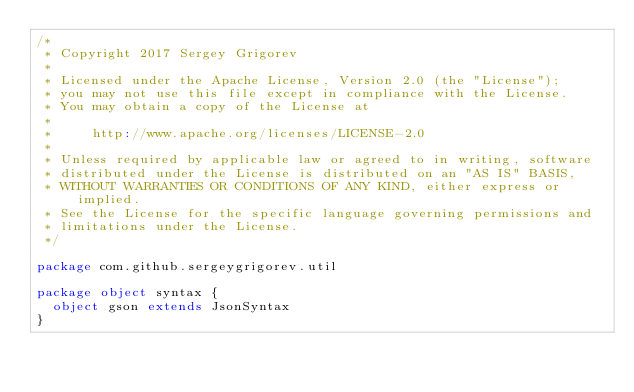<code> <loc_0><loc_0><loc_500><loc_500><_Scala_>/*
 * Copyright 2017 Sergey Grigorev
 *
 * Licensed under the Apache License, Version 2.0 (the "License");
 * you may not use this file except in compliance with the License.
 * You may obtain a copy of the License at
 *
 *     http://www.apache.org/licenses/LICENSE-2.0
 *
 * Unless required by applicable law or agreed to in writing, software
 * distributed under the License is distributed on an "AS IS" BASIS,
 * WITHOUT WARRANTIES OR CONDITIONS OF ANY KIND, either express or implied.
 * See the License for the specific language governing permissions and
 * limitations under the License.
 */

package com.github.sergeygrigorev.util

package object syntax {
  object gson extends JsonSyntax
}
</code> 